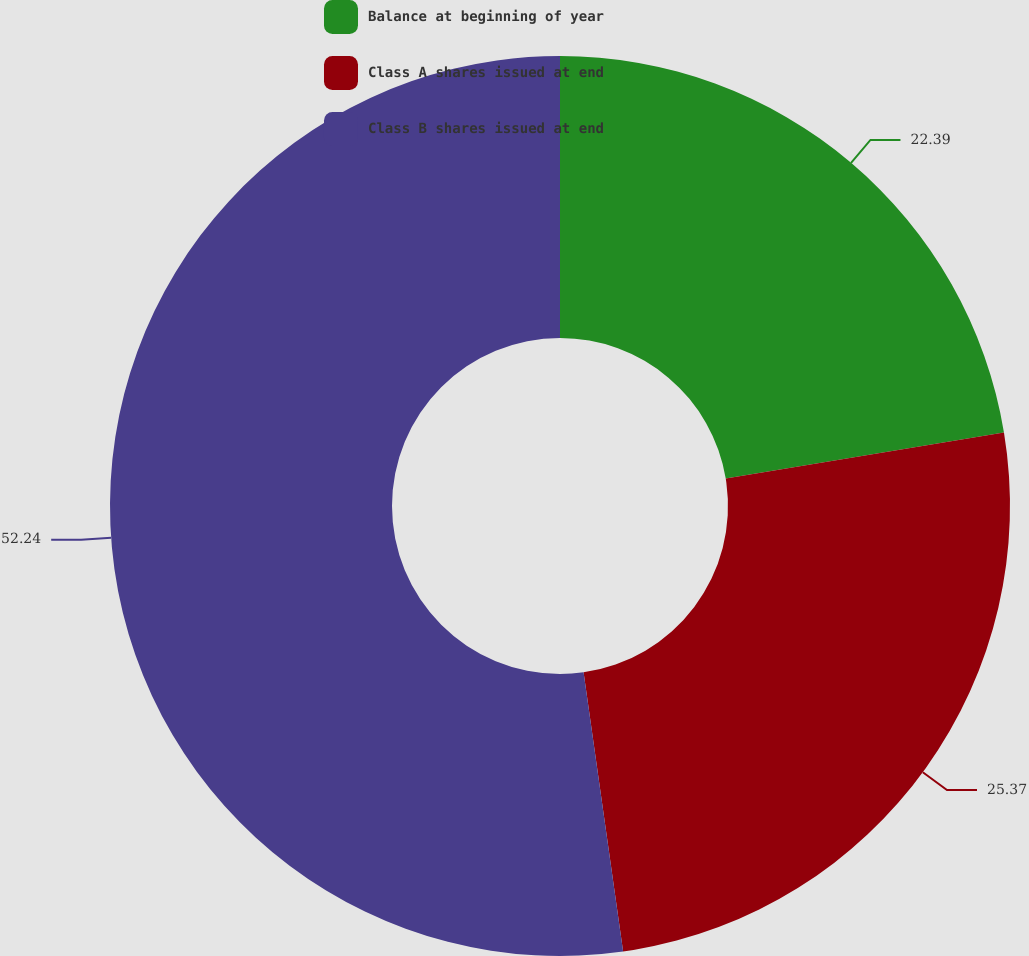Convert chart. <chart><loc_0><loc_0><loc_500><loc_500><pie_chart><fcel>Balance at beginning of year<fcel>Class A shares issued at end<fcel>Class B shares issued at end<nl><fcel>22.39%<fcel>25.37%<fcel>52.24%<nl></chart> 